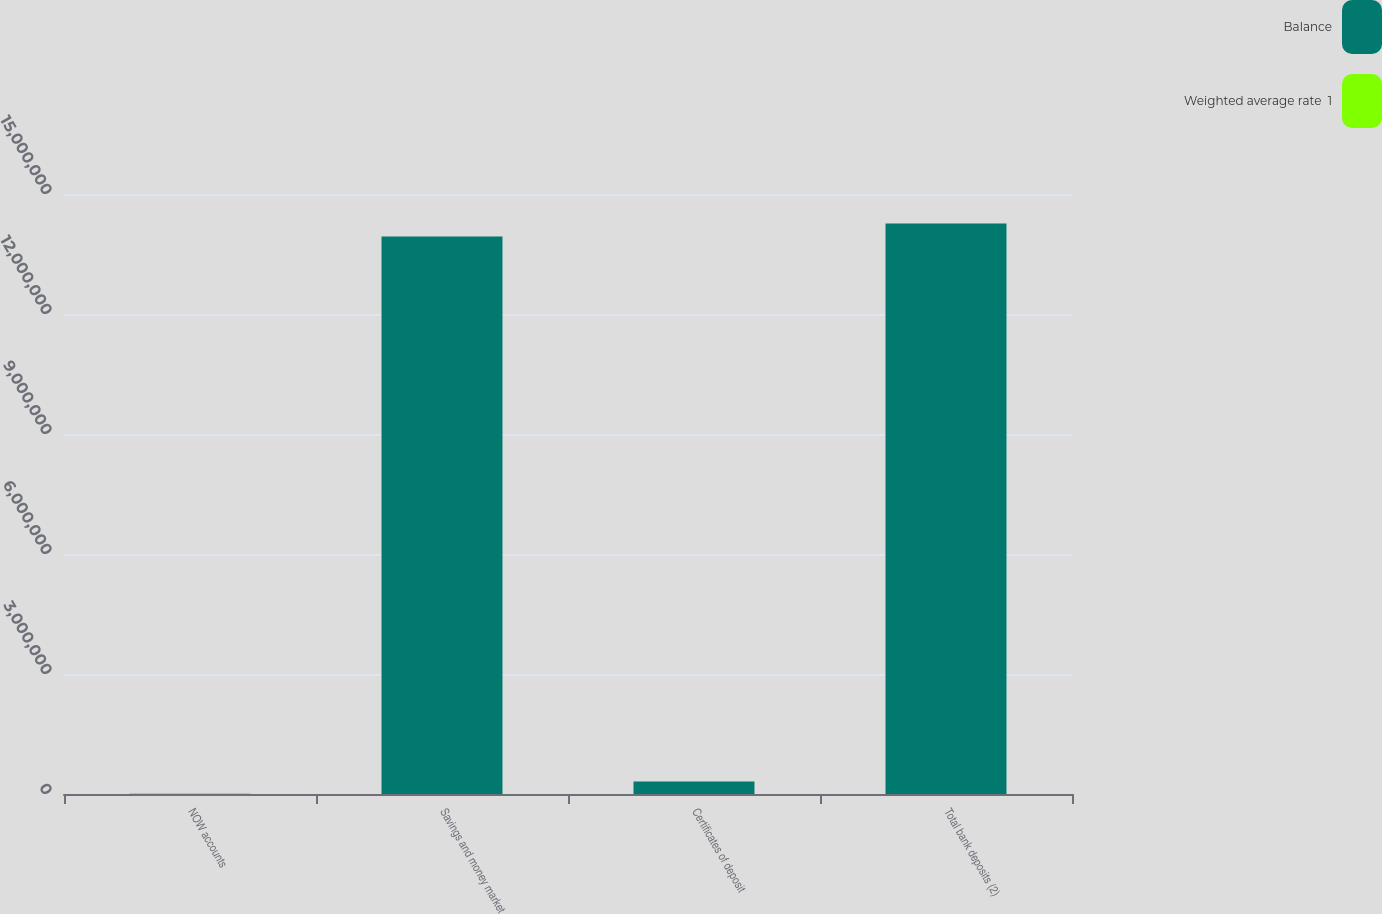<chart> <loc_0><loc_0><loc_500><loc_500><stacked_bar_chart><ecel><fcel>NOW accounts<fcel>Savings and money market<fcel>Certificates of deposit<fcel>Total bank deposits (2)<nl><fcel>Balance<fcel>4958<fcel>1.39351e+07<fcel>315236<fcel>1.42625e+07<nl><fcel>Weighted average rate  1<fcel>0.01<fcel>0.05<fcel>1.55<fcel>0.08<nl></chart> 